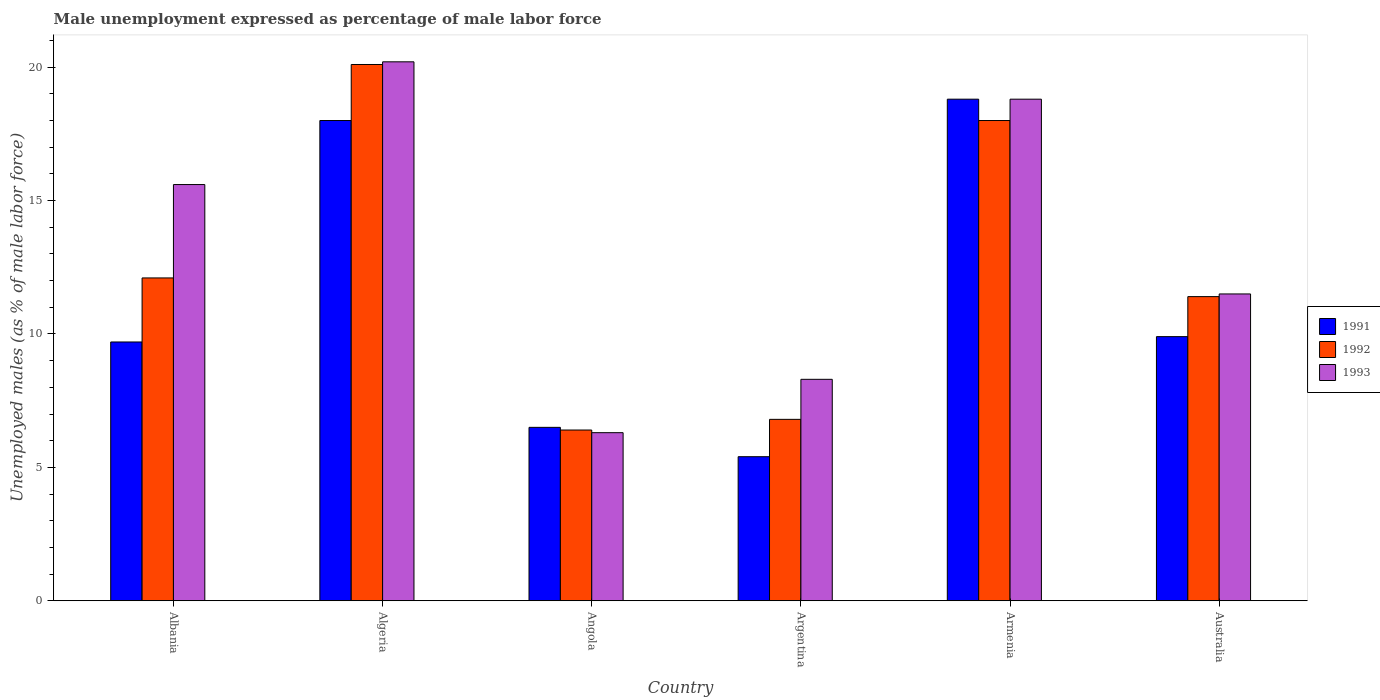How many different coloured bars are there?
Provide a succinct answer. 3. Are the number of bars per tick equal to the number of legend labels?
Provide a short and direct response. Yes. Are the number of bars on each tick of the X-axis equal?
Your answer should be very brief. Yes. How many bars are there on the 3rd tick from the left?
Give a very brief answer. 3. How many bars are there on the 6th tick from the right?
Offer a very short reply. 3. What is the label of the 5th group of bars from the left?
Offer a very short reply. Armenia. In how many cases, is the number of bars for a given country not equal to the number of legend labels?
Your answer should be compact. 0. What is the unemployment in males in in 1993 in Albania?
Provide a short and direct response. 15.6. Across all countries, what is the maximum unemployment in males in in 1993?
Your answer should be compact. 20.2. Across all countries, what is the minimum unemployment in males in in 1993?
Offer a terse response. 6.3. In which country was the unemployment in males in in 1992 maximum?
Your response must be concise. Algeria. In which country was the unemployment in males in in 1992 minimum?
Provide a succinct answer. Angola. What is the total unemployment in males in in 1993 in the graph?
Your response must be concise. 80.7. What is the difference between the unemployment in males in in 1991 in Algeria and that in Armenia?
Give a very brief answer. -0.8. What is the difference between the unemployment in males in in 1992 in Australia and the unemployment in males in in 1993 in Albania?
Keep it short and to the point. -4.2. What is the average unemployment in males in in 1993 per country?
Your response must be concise. 13.45. What is the difference between the unemployment in males in of/in 1992 and unemployment in males in of/in 1993 in Armenia?
Your answer should be compact. -0.8. In how many countries, is the unemployment in males in in 1993 greater than 13 %?
Keep it short and to the point. 3. What is the ratio of the unemployment in males in in 1991 in Angola to that in Argentina?
Provide a short and direct response. 1.2. What is the difference between the highest and the second highest unemployment in males in in 1993?
Give a very brief answer. -1.4. What is the difference between the highest and the lowest unemployment in males in in 1992?
Make the answer very short. 13.7. What does the 1st bar from the left in Australia represents?
Your response must be concise. 1991. What does the 2nd bar from the right in Algeria represents?
Give a very brief answer. 1992. How many bars are there?
Ensure brevity in your answer.  18. How many countries are there in the graph?
Provide a short and direct response. 6. Are the values on the major ticks of Y-axis written in scientific E-notation?
Ensure brevity in your answer.  No. Does the graph contain any zero values?
Give a very brief answer. No. Where does the legend appear in the graph?
Your answer should be very brief. Center right. What is the title of the graph?
Offer a very short reply. Male unemployment expressed as percentage of male labor force. Does "1988" appear as one of the legend labels in the graph?
Give a very brief answer. No. What is the label or title of the Y-axis?
Your response must be concise. Unemployed males (as % of male labor force). What is the Unemployed males (as % of male labor force) of 1991 in Albania?
Give a very brief answer. 9.7. What is the Unemployed males (as % of male labor force) in 1992 in Albania?
Offer a terse response. 12.1. What is the Unemployed males (as % of male labor force) of 1993 in Albania?
Make the answer very short. 15.6. What is the Unemployed males (as % of male labor force) of 1992 in Algeria?
Provide a succinct answer. 20.1. What is the Unemployed males (as % of male labor force) in 1993 in Algeria?
Make the answer very short. 20.2. What is the Unemployed males (as % of male labor force) of 1992 in Angola?
Offer a terse response. 6.4. What is the Unemployed males (as % of male labor force) of 1993 in Angola?
Offer a very short reply. 6.3. What is the Unemployed males (as % of male labor force) of 1991 in Argentina?
Give a very brief answer. 5.4. What is the Unemployed males (as % of male labor force) in 1992 in Argentina?
Your response must be concise. 6.8. What is the Unemployed males (as % of male labor force) of 1993 in Argentina?
Ensure brevity in your answer.  8.3. What is the Unemployed males (as % of male labor force) in 1991 in Armenia?
Offer a very short reply. 18.8. What is the Unemployed males (as % of male labor force) of 1992 in Armenia?
Provide a short and direct response. 18. What is the Unemployed males (as % of male labor force) of 1993 in Armenia?
Your answer should be compact. 18.8. What is the Unemployed males (as % of male labor force) of 1991 in Australia?
Keep it short and to the point. 9.9. What is the Unemployed males (as % of male labor force) of 1992 in Australia?
Make the answer very short. 11.4. Across all countries, what is the maximum Unemployed males (as % of male labor force) in 1991?
Offer a terse response. 18.8. Across all countries, what is the maximum Unemployed males (as % of male labor force) in 1992?
Offer a very short reply. 20.1. Across all countries, what is the maximum Unemployed males (as % of male labor force) of 1993?
Offer a terse response. 20.2. Across all countries, what is the minimum Unemployed males (as % of male labor force) of 1991?
Your response must be concise. 5.4. Across all countries, what is the minimum Unemployed males (as % of male labor force) in 1992?
Give a very brief answer. 6.4. Across all countries, what is the minimum Unemployed males (as % of male labor force) in 1993?
Offer a terse response. 6.3. What is the total Unemployed males (as % of male labor force) of 1991 in the graph?
Offer a very short reply. 68.3. What is the total Unemployed males (as % of male labor force) in 1992 in the graph?
Your answer should be very brief. 74.8. What is the total Unemployed males (as % of male labor force) in 1993 in the graph?
Offer a terse response. 80.7. What is the difference between the Unemployed males (as % of male labor force) in 1991 in Albania and that in Algeria?
Provide a short and direct response. -8.3. What is the difference between the Unemployed males (as % of male labor force) in 1992 in Albania and that in Algeria?
Your answer should be very brief. -8. What is the difference between the Unemployed males (as % of male labor force) of 1993 in Albania and that in Algeria?
Offer a very short reply. -4.6. What is the difference between the Unemployed males (as % of male labor force) in 1993 in Albania and that in Angola?
Offer a very short reply. 9.3. What is the difference between the Unemployed males (as % of male labor force) in 1991 in Albania and that in Argentina?
Make the answer very short. 4.3. What is the difference between the Unemployed males (as % of male labor force) of 1992 in Albania and that in Argentina?
Offer a terse response. 5.3. What is the difference between the Unemployed males (as % of male labor force) of 1992 in Albania and that in Armenia?
Make the answer very short. -5.9. What is the difference between the Unemployed males (as % of male labor force) in 1993 in Albania and that in Armenia?
Offer a very short reply. -3.2. What is the difference between the Unemployed males (as % of male labor force) in 1992 in Albania and that in Australia?
Offer a terse response. 0.7. What is the difference between the Unemployed males (as % of male labor force) of 1991 in Algeria and that in Angola?
Offer a terse response. 11.5. What is the difference between the Unemployed males (as % of male labor force) of 1992 in Algeria and that in Angola?
Your response must be concise. 13.7. What is the difference between the Unemployed males (as % of male labor force) in 1993 in Algeria and that in Angola?
Give a very brief answer. 13.9. What is the difference between the Unemployed males (as % of male labor force) of 1991 in Algeria and that in Argentina?
Your response must be concise. 12.6. What is the difference between the Unemployed males (as % of male labor force) of 1993 in Algeria and that in Argentina?
Offer a terse response. 11.9. What is the difference between the Unemployed males (as % of male labor force) in 1992 in Algeria and that in Armenia?
Your response must be concise. 2.1. What is the difference between the Unemployed males (as % of male labor force) in 1991 in Angola and that in Argentina?
Provide a succinct answer. 1.1. What is the difference between the Unemployed males (as % of male labor force) of 1991 in Angola and that in Armenia?
Provide a succinct answer. -12.3. What is the difference between the Unemployed males (as % of male labor force) of 1992 in Angola and that in Armenia?
Your response must be concise. -11.6. What is the difference between the Unemployed males (as % of male labor force) in 1993 in Angola and that in Australia?
Your response must be concise. -5.2. What is the difference between the Unemployed males (as % of male labor force) in 1993 in Argentina and that in Armenia?
Offer a very short reply. -10.5. What is the difference between the Unemployed males (as % of male labor force) of 1991 in Argentina and that in Australia?
Offer a very short reply. -4.5. What is the difference between the Unemployed males (as % of male labor force) in 1992 in Argentina and that in Australia?
Your response must be concise. -4.6. What is the difference between the Unemployed males (as % of male labor force) of 1993 in Argentina and that in Australia?
Your answer should be compact. -3.2. What is the difference between the Unemployed males (as % of male labor force) in 1991 in Armenia and that in Australia?
Make the answer very short. 8.9. What is the difference between the Unemployed males (as % of male labor force) in 1992 in Armenia and that in Australia?
Your answer should be compact. 6.6. What is the difference between the Unemployed males (as % of male labor force) in 1991 in Albania and the Unemployed males (as % of male labor force) in 1992 in Angola?
Offer a very short reply. 3.3. What is the difference between the Unemployed males (as % of male labor force) of 1991 in Albania and the Unemployed males (as % of male labor force) of 1993 in Angola?
Keep it short and to the point. 3.4. What is the difference between the Unemployed males (as % of male labor force) of 1992 in Albania and the Unemployed males (as % of male labor force) of 1993 in Angola?
Your answer should be very brief. 5.8. What is the difference between the Unemployed males (as % of male labor force) of 1991 in Algeria and the Unemployed males (as % of male labor force) of 1992 in Angola?
Offer a very short reply. 11.6. What is the difference between the Unemployed males (as % of male labor force) of 1992 in Algeria and the Unemployed males (as % of male labor force) of 1993 in Angola?
Your answer should be compact. 13.8. What is the difference between the Unemployed males (as % of male labor force) of 1991 in Algeria and the Unemployed males (as % of male labor force) of 1992 in Argentina?
Give a very brief answer. 11.2. What is the difference between the Unemployed males (as % of male labor force) of 1991 in Algeria and the Unemployed males (as % of male labor force) of 1993 in Argentina?
Your answer should be compact. 9.7. What is the difference between the Unemployed males (as % of male labor force) in 1991 in Algeria and the Unemployed males (as % of male labor force) in 1992 in Armenia?
Your answer should be very brief. 0. What is the difference between the Unemployed males (as % of male labor force) of 1992 in Algeria and the Unemployed males (as % of male labor force) of 1993 in Armenia?
Ensure brevity in your answer.  1.3. What is the difference between the Unemployed males (as % of male labor force) in 1991 in Algeria and the Unemployed males (as % of male labor force) in 1992 in Australia?
Your answer should be very brief. 6.6. What is the difference between the Unemployed males (as % of male labor force) in 1991 in Angola and the Unemployed males (as % of male labor force) in 1992 in Armenia?
Make the answer very short. -11.5. What is the difference between the Unemployed males (as % of male labor force) of 1991 in Angola and the Unemployed males (as % of male labor force) of 1993 in Australia?
Provide a succinct answer. -5. What is the difference between the Unemployed males (as % of male labor force) in 1991 in Argentina and the Unemployed males (as % of male labor force) in 1992 in Armenia?
Your answer should be very brief. -12.6. What is the difference between the Unemployed males (as % of male labor force) of 1991 in Argentina and the Unemployed males (as % of male labor force) of 1993 in Armenia?
Provide a succinct answer. -13.4. What is the difference between the Unemployed males (as % of male labor force) in 1992 in Argentina and the Unemployed males (as % of male labor force) in 1993 in Armenia?
Your answer should be very brief. -12. What is the difference between the Unemployed males (as % of male labor force) in 1991 in Argentina and the Unemployed males (as % of male labor force) in 1992 in Australia?
Make the answer very short. -6. What is the difference between the Unemployed males (as % of male labor force) of 1992 in Argentina and the Unemployed males (as % of male labor force) of 1993 in Australia?
Make the answer very short. -4.7. What is the difference between the Unemployed males (as % of male labor force) in 1991 in Armenia and the Unemployed males (as % of male labor force) in 1992 in Australia?
Provide a succinct answer. 7.4. What is the average Unemployed males (as % of male labor force) of 1991 per country?
Offer a terse response. 11.38. What is the average Unemployed males (as % of male labor force) in 1992 per country?
Ensure brevity in your answer.  12.47. What is the average Unemployed males (as % of male labor force) of 1993 per country?
Provide a short and direct response. 13.45. What is the difference between the Unemployed males (as % of male labor force) of 1992 and Unemployed males (as % of male labor force) of 1993 in Albania?
Offer a terse response. -3.5. What is the difference between the Unemployed males (as % of male labor force) in 1991 and Unemployed males (as % of male labor force) in 1992 in Algeria?
Provide a short and direct response. -2.1. What is the difference between the Unemployed males (as % of male labor force) of 1991 and Unemployed males (as % of male labor force) of 1992 in Angola?
Offer a terse response. 0.1. What is the difference between the Unemployed males (as % of male labor force) of 1992 and Unemployed males (as % of male labor force) of 1993 in Angola?
Offer a very short reply. 0.1. What is the difference between the Unemployed males (as % of male labor force) of 1991 and Unemployed males (as % of male labor force) of 1992 in Argentina?
Make the answer very short. -1.4. What is the difference between the Unemployed males (as % of male labor force) in 1991 and Unemployed males (as % of male labor force) in 1993 in Argentina?
Offer a terse response. -2.9. What is the difference between the Unemployed males (as % of male labor force) in 1991 and Unemployed males (as % of male labor force) in 1992 in Armenia?
Your response must be concise. 0.8. What is the difference between the Unemployed males (as % of male labor force) in 1991 and Unemployed males (as % of male labor force) in 1993 in Armenia?
Offer a terse response. 0. What is the difference between the Unemployed males (as % of male labor force) in 1991 and Unemployed males (as % of male labor force) in 1992 in Australia?
Offer a terse response. -1.5. What is the difference between the Unemployed males (as % of male labor force) of 1992 and Unemployed males (as % of male labor force) of 1993 in Australia?
Offer a terse response. -0.1. What is the ratio of the Unemployed males (as % of male labor force) of 1991 in Albania to that in Algeria?
Provide a short and direct response. 0.54. What is the ratio of the Unemployed males (as % of male labor force) of 1992 in Albania to that in Algeria?
Keep it short and to the point. 0.6. What is the ratio of the Unemployed males (as % of male labor force) of 1993 in Albania to that in Algeria?
Your answer should be compact. 0.77. What is the ratio of the Unemployed males (as % of male labor force) of 1991 in Albania to that in Angola?
Your answer should be compact. 1.49. What is the ratio of the Unemployed males (as % of male labor force) in 1992 in Albania to that in Angola?
Offer a very short reply. 1.89. What is the ratio of the Unemployed males (as % of male labor force) of 1993 in Albania to that in Angola?
Make the answer very short. 2.48. What is the ratio of the Unemployed males (as % of male labor force) in 1991 in Albania to that in Argentina?
Offer a very short reply. 1.8. What is the ratio of the Unemployed males (as % of male labor force) in 1992 in Albania to that in Argentina?
Your response must be concise. 1.78. What is the ratio of the Unemployed males (as % of male labor force) of 1993 in Albania to that in Argentina?
Provide a succinct answer. 1.88. What is the ratio of the Unemployed males (as % of male labor force) in 1991 in Albania to that in Armenia?
Provide a succinct answer. 0.52. What is the ratio of the Unemployed males (as % of male labor force) in 1992 in Albania to that in Armenia?
Your response must be concise. 0.67. What is the ratio of the Unemployed males (as % of male labor force) in 1993 in Albania to that in Armenia?
Offer a very short reply. 0.83. What is the ratio of the Unemployed males (as % of male labor force) of 1991 in Albania to that in Australia?
Your response must be concise. 0.98. What is the ratio of the Unemployed males (as % of male labor force) of 1992 in Albania to that in Australia?
Your answer should be compact. 1.06. What is the ratio of the Unemployed males (as % of male labor force) in 1993 in Albania to that in Australia?
Ensure brevity in your answer.  1.36. What is the ratio of the Unemployed males (as % of male labor force) of 1991 in Algeria to that in Angola?
Give a very brief answer. 2.77. What is the ratio of the Unemployed males (as % of male labor force) in 1992 in Algeria to that in Angola?
Give a very brief answer. 3.14. What is the ratio of the Unemployed males (as % of male labor force) in 1993 in Algeria to that in Angola?
Provide a succinct answer. 3.21. What is the ratio of the Unemployed males (as % of male labor force) of 1992 in Algeria to that in Argentina?
Ensure brevity in your answer.  2.96. What is the ratio of the Unemployed males (as % of male labor force) in 1993 in Algeria to that in Argentina?
Your answer should be compact. 2.43. What is the ratio of the Unemployed males (as % of male labor force) in 1991 in Algeria to that in Armenia?
Your response must be concise. 0.96. What is the ratio of the Unemployed males (as % of male labor force) of 1992 in Algeria to that in Armenia?
Your answer should be very brief. 1.12. What is the ratio of the Unemployed males (as % of male labor force) in 1993 in Algeria to that in Armenia?
Provide a succinct answer. 1.07. What is the ratio of the Unemployed males (as % of male labor force) of 1991 in Algeria to that in Australia?
Offer a very short reply. 1.82. What is the ratio of the Unemployed males (as % of male labor force) of 1992 in Algeria to that in Australia?
Ensure brevity in your answer.  1.76. What is the ratio of the Unemployed males (as % of male labor force) in 1993 in Algeria to that in Australia?
Make the answer very short. 1.76. What is the ratio of the Unemployed males (as % of male labor force) in 1991 in Angola to that in Argentina?
Make the answer very short. 1.2. What is the ratio of the Unemployed males (as % of male labor force) of 1992 in Angola to that in Argentina?
Your answer should be compact. 0.94. What is the ratio of the Unemployed males (as % of male labor force) in 1993 in Angola to that in Argentina?
Provide a short and direct response. 0.76. What is the ratio of the Unemployed males (as % of male labor force) of 1991 in Angola to that in Armenia?
Ensure brevity in your answer.  0.35. What is the ratio of the Unemployed males (as % of male labor force) in 1992 in Angola to that in Armenia?
Offer a very short reply. 0.36. What is the ratio of the Unemployed males (as % of male labor force) in 1993 in Angola to that in Armenia?
Give a very brief answer. 0.34. What is the ratio of the Unemployed males (as % of male labor force) in 1991 in Angola to that in Australia?
Ensure brevity in your answer.  0.66. What is the ratio of the Unemployed males (as % of male labor force) of 1992 in Angola to that in Australia?
Offer a very short reply. 0.56. What is the ratio of the Unemployed males (as % of male labor force) in 1993 in Angola to that in Australia?
Your response must be concise. 0.55. What is the ratio of the Unemployed males (as % of male labor force) in 1991 in Argentina to that in Armenia?
Provide a succinct answer. 0.29. What is the ratio of the Unemployed males (as % of male labor force) of 1992 in Argentina to that in Armenia?
Your response must be concise. 0.38. What is the ratio of the Unemployed males (as % of male labor force) in 1993 in Argentina to that in Armenia?
Your answer should be very brief. 0.44. What is the ratio of the Unemployed males (as % of male labor force) in 1991 in Argentina to that in Australia?
Offer a terse response. 0.55. What is the ratio of the Unemployed males (as % of male labor force) in 1992 in Argentina to that in Australia?
Make the answer very short. 0.6. What is the ratio of the Unemployed males (as % of male labor force) in 1993 in Argentina to that in Australia?
Provide a succinct answer. 0.72. What is the ratio of the Unemployed males (as % of male labor force) in 1991 in Armenia to that in Australia?
Your answer should be compact. 1.9. What is the ratio of the Unemployed males (as % of male labor force) in 1992 in Armenia to that in Australia?
Your response must be concise. 1.58. What is the ratio of the Unemployed males (as % of male labor force) in 1993 in Armenia to that in Australia?
Your answer should be very brief. 1.63. What is the difference between the highest and the second highest Unemployed males (as % of male labor force) in 1991?
Offer a terse response. 0.8. What is the difference between the highest and the second highest Unemployed males (as % of male labor force) of 1992?
Provide a succinct answer. 2.1. What is the difference between the highest and the lowest Unemployed males (as % of male labor force) in 1991?
Make the answer very short. 13.4. What is the difference between the highest and the lowest Unemployed males (as % of male labor force) of 1992?
Ensure brevity in your answer.  13.7. What is the difference between the highest and the lowest Unemployed males (as % of male labor force) of 1993?
Keep it short and to the point. 13.9. 